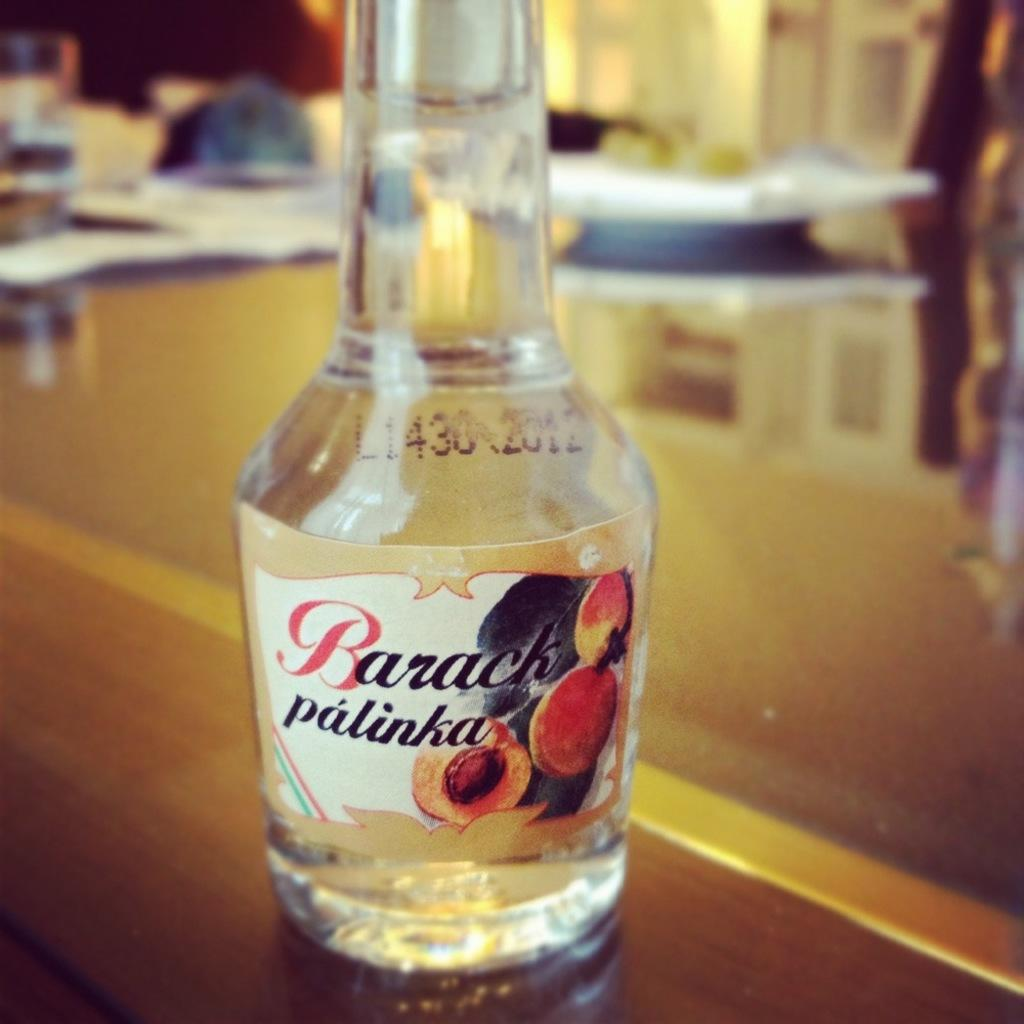What piece of furniture is present in the image? There is a table in the image. What object is placed on the table? There is a bottle on the table. What can be found on the bottle? There is text on the bottle. Can you tell me what type of fish is swimming in the bottle? There is no fish present in the image; the bottle contains text. 